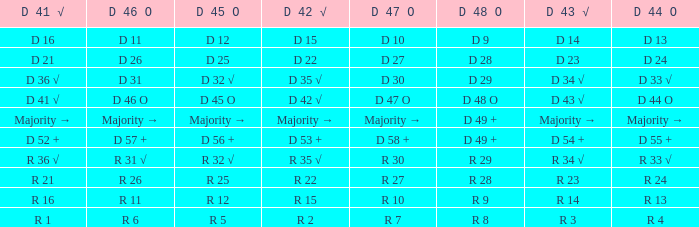Name the D 45 O with D 46 O of r 31 √ R 32 √. 